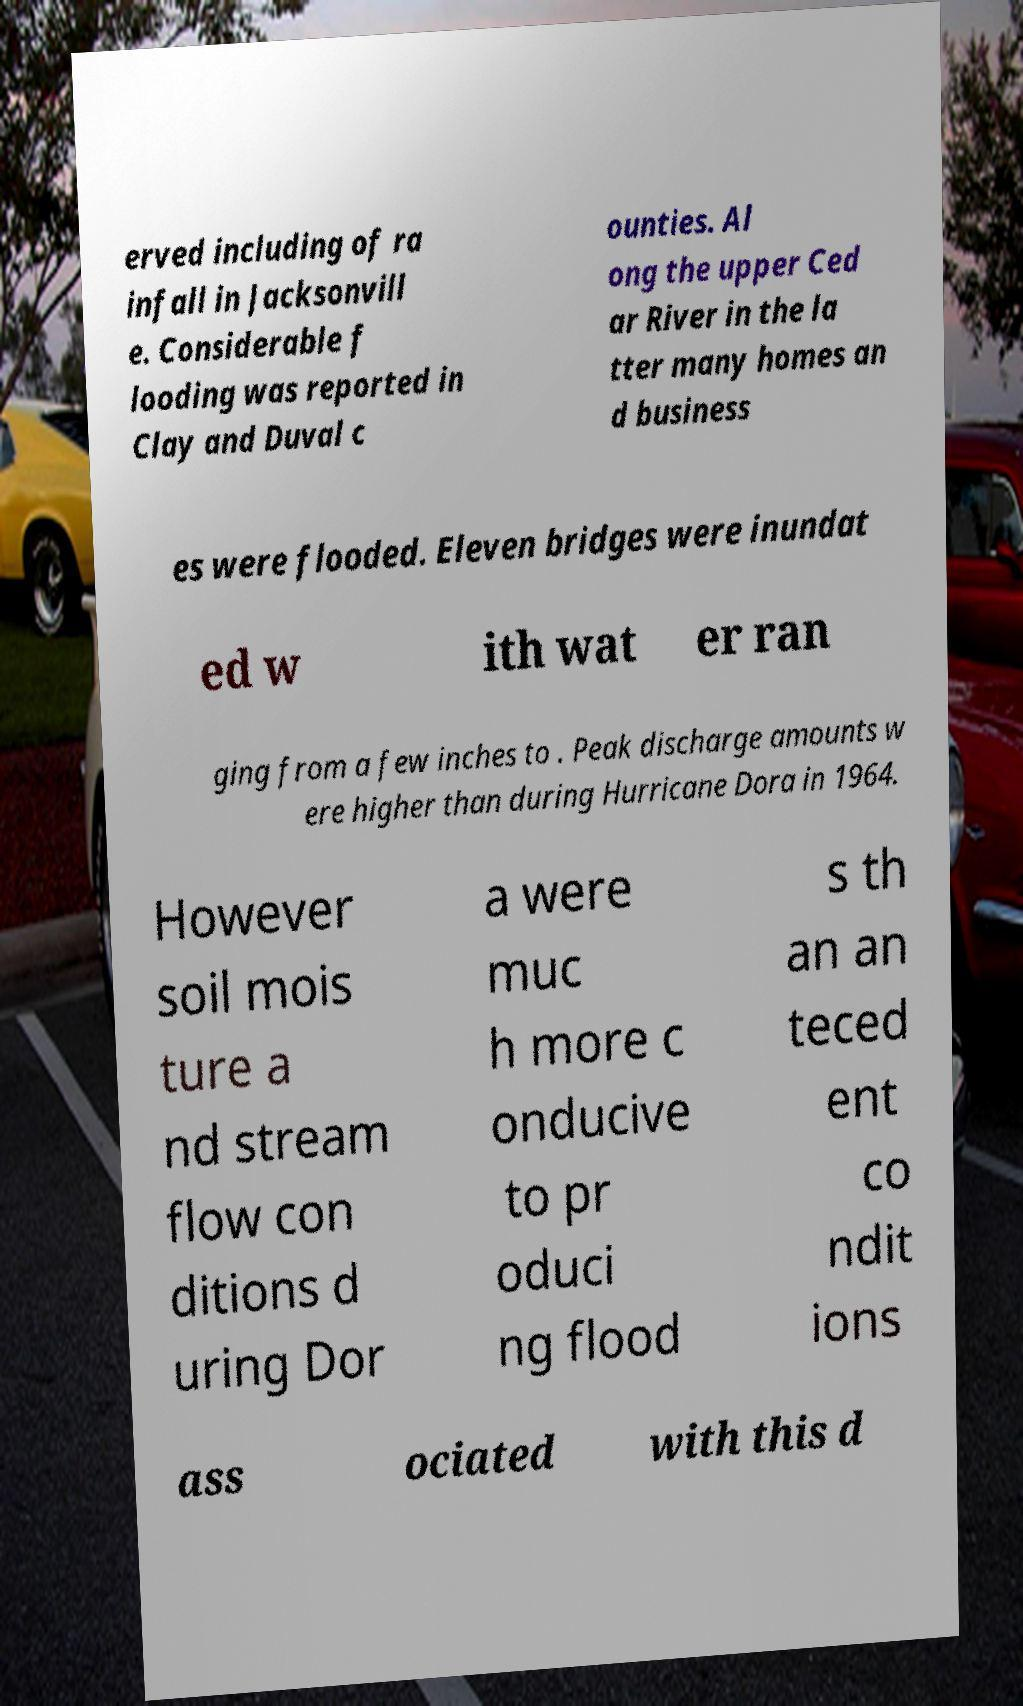Could you extract and type out the text from this image? erved including of ra infall in Jacksonvill e. Considerable f looding was reported in Clay and Duval c ounties. Al ong the upper Ced ar River in the la tter many homes an d business es were flooded. Eleven bridges were inundat ed w ith wat er ran ging from a few inches to . Peak discharge amounts w ere higher than during Hurricane Dora in 1964. However soil mois ture a nd stream flow con ditions d uring Dor a were muc h more c onducive to pr oduci ng flood s th an an teced ent co ndit ions ass ociated with this d 